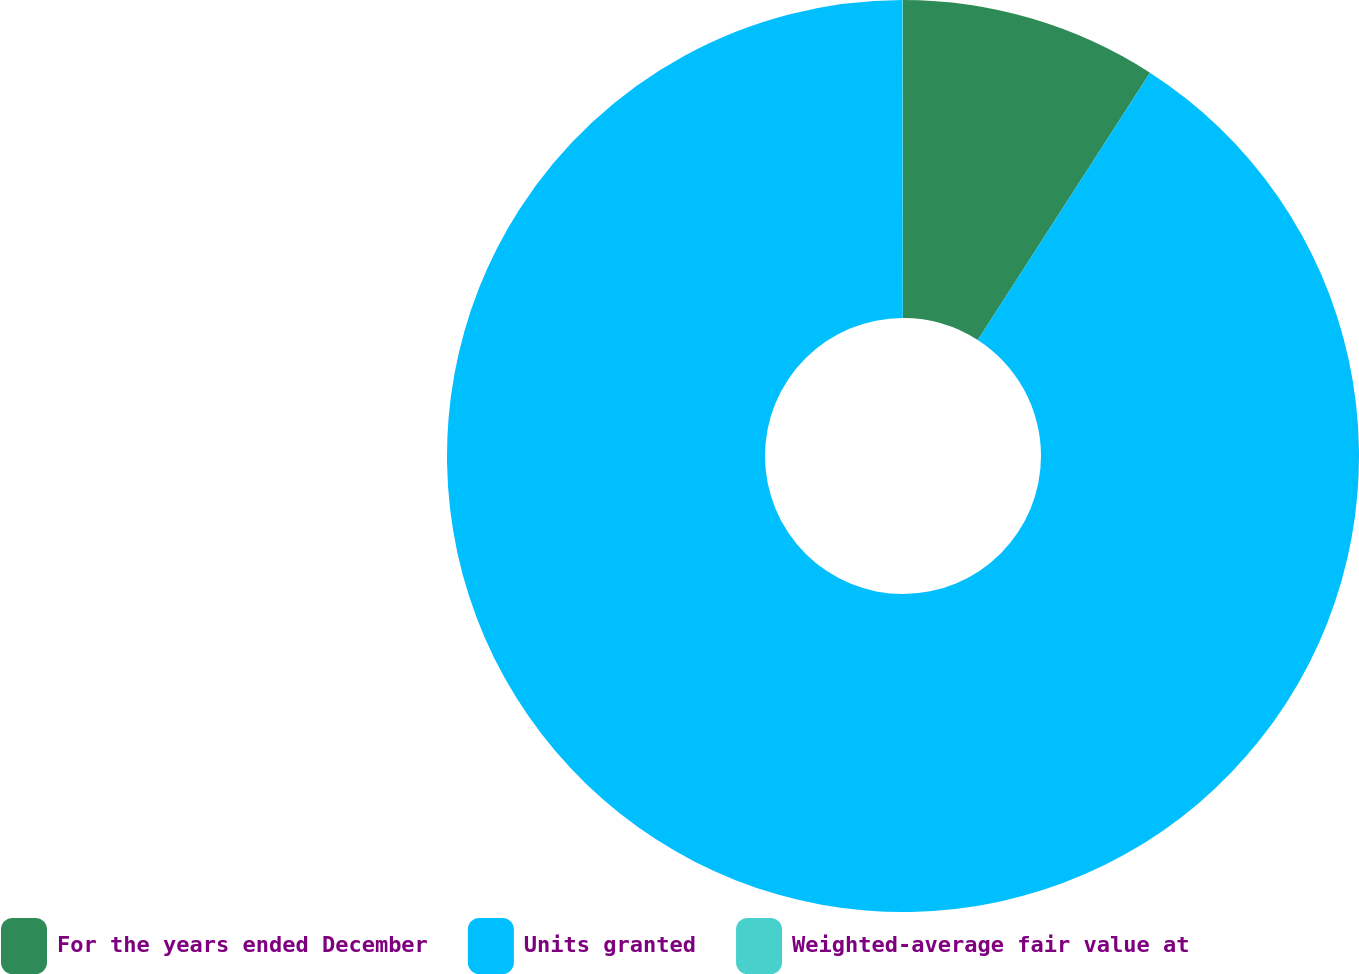Convert chart. <chart><loc_0><loc_0><loc_500><loc_500><pie_chart><fcel>For the years ended December<fcel>Units granted<fcel>Weighted-average fair value at<nl><fcel>9.11%<fcel>90.87%<fcel>0.02%<nl></chart> 